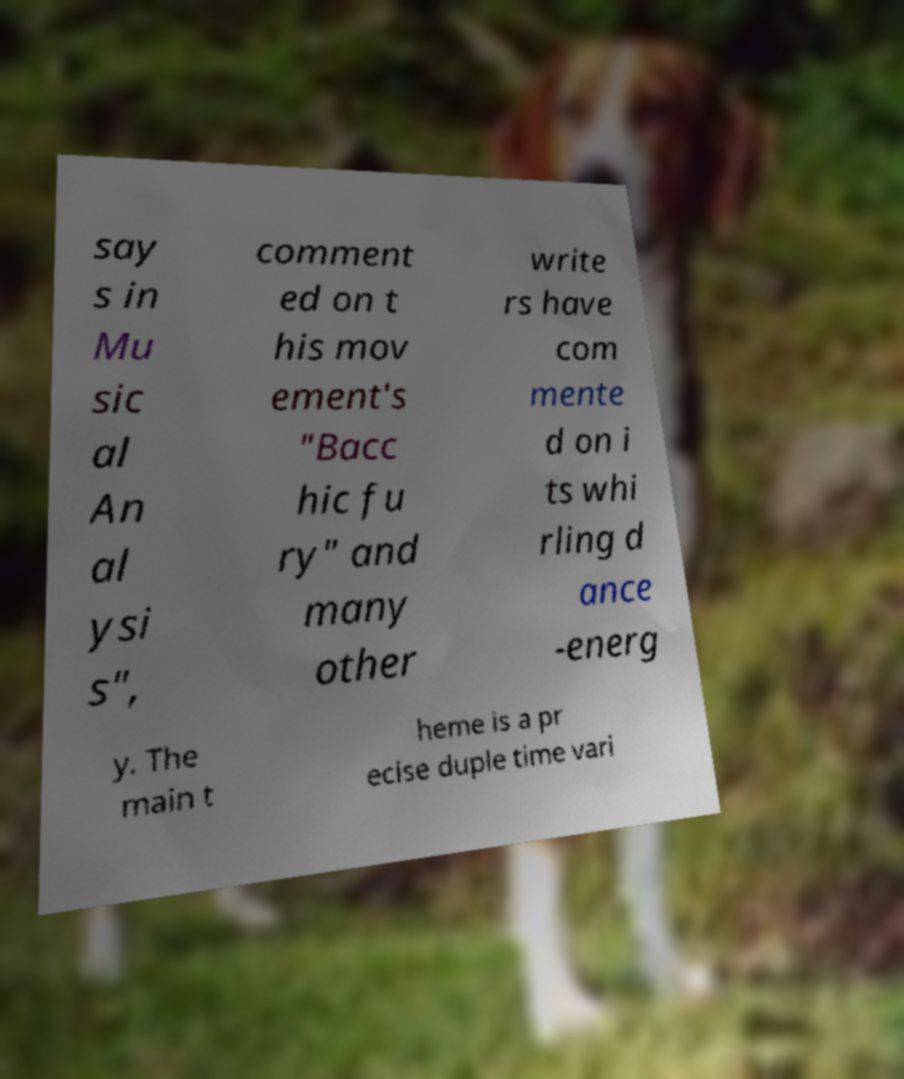Please read and relay the text visible in this image. What does it say? say s in Mu sic al An al ysi s", comment ed on t his mov ement's "Bacc hic fu ry" and many other write rs have com mente d on i ts whi rling d ance -energ y. The main t heme is a pr ecise duple time vari 